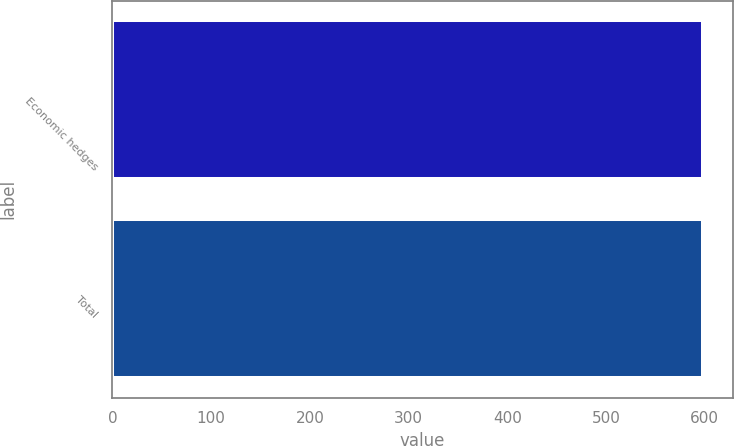Convert chart. <chart><loc_0><loc_0><loc_500><loc_500><bar_chart><fcel>Economic hedges<fcel>Total<nl><fcel>598<fcel>598.1<nl></chart> 